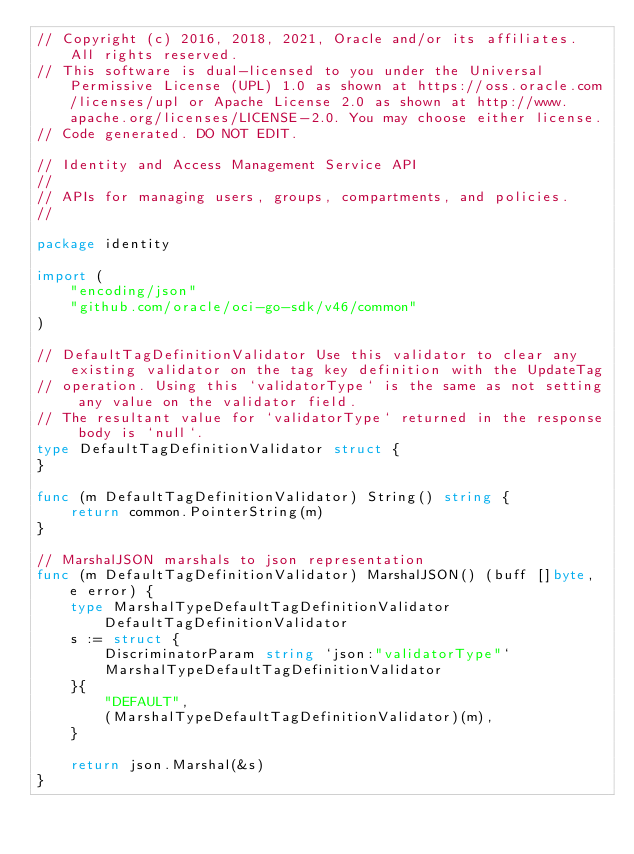Convert code to text. <code><loc_0><loc_0><loc_500><loc_500><_Go_>// Copyright (c) 2016, 2018, 2021, Oracle and/or its affiliates.  All rights reserved.
// This software is dual-licensed to you under the Universal Permissive License (UPL) 1.0 as shown at https://oss.oracle.com/licenses/upl or Apache License 2.0 as shown at http://www.apache.org/licenses/LICENSE-2.0. You may choose either license.
// Code generated. DO NOT EDIT.

// Identity and Access Management Service API
//
// APIs for managing users, groups, compartments, and policies.
//

package identity

import (
	"encoding/json"
	"github.com/oracle/oci-go-sdk/v46/common"
)

// DefaultTagDefinitionValidator Use this validator to clear any existing validator on the tag key definition with the UpdateTag
// operation. Using this `validatorType` is the same as not setting any value on the validator field.
// The resultant value for `validatorType` returned in the response body is `null`.
type DefaultTagDefinitionValidator struct {
}

func (m DefaultTagDefinitionValidator) String() string {
	return common.PointerString(m)
}

// MarshalJSON marshals to json representation
func (m DefaultTagDefinitionValidator) MarshalJSON() (buff []byte, e error) {
	type MarshalTypeDefaultTagDefinitionValidator DefaultTagDefinitionValidator
	s := struct {
		DiscriminatorParam string `json:"validatorType"`
		MarshalTypeDefaultTagDefinitionValidator
	}{
		"DEFAULT",
		(MarshalTypeDefaultTagDefinitionValidator)(m),
	}

	return json.Marshal(&s)
}
</code> 